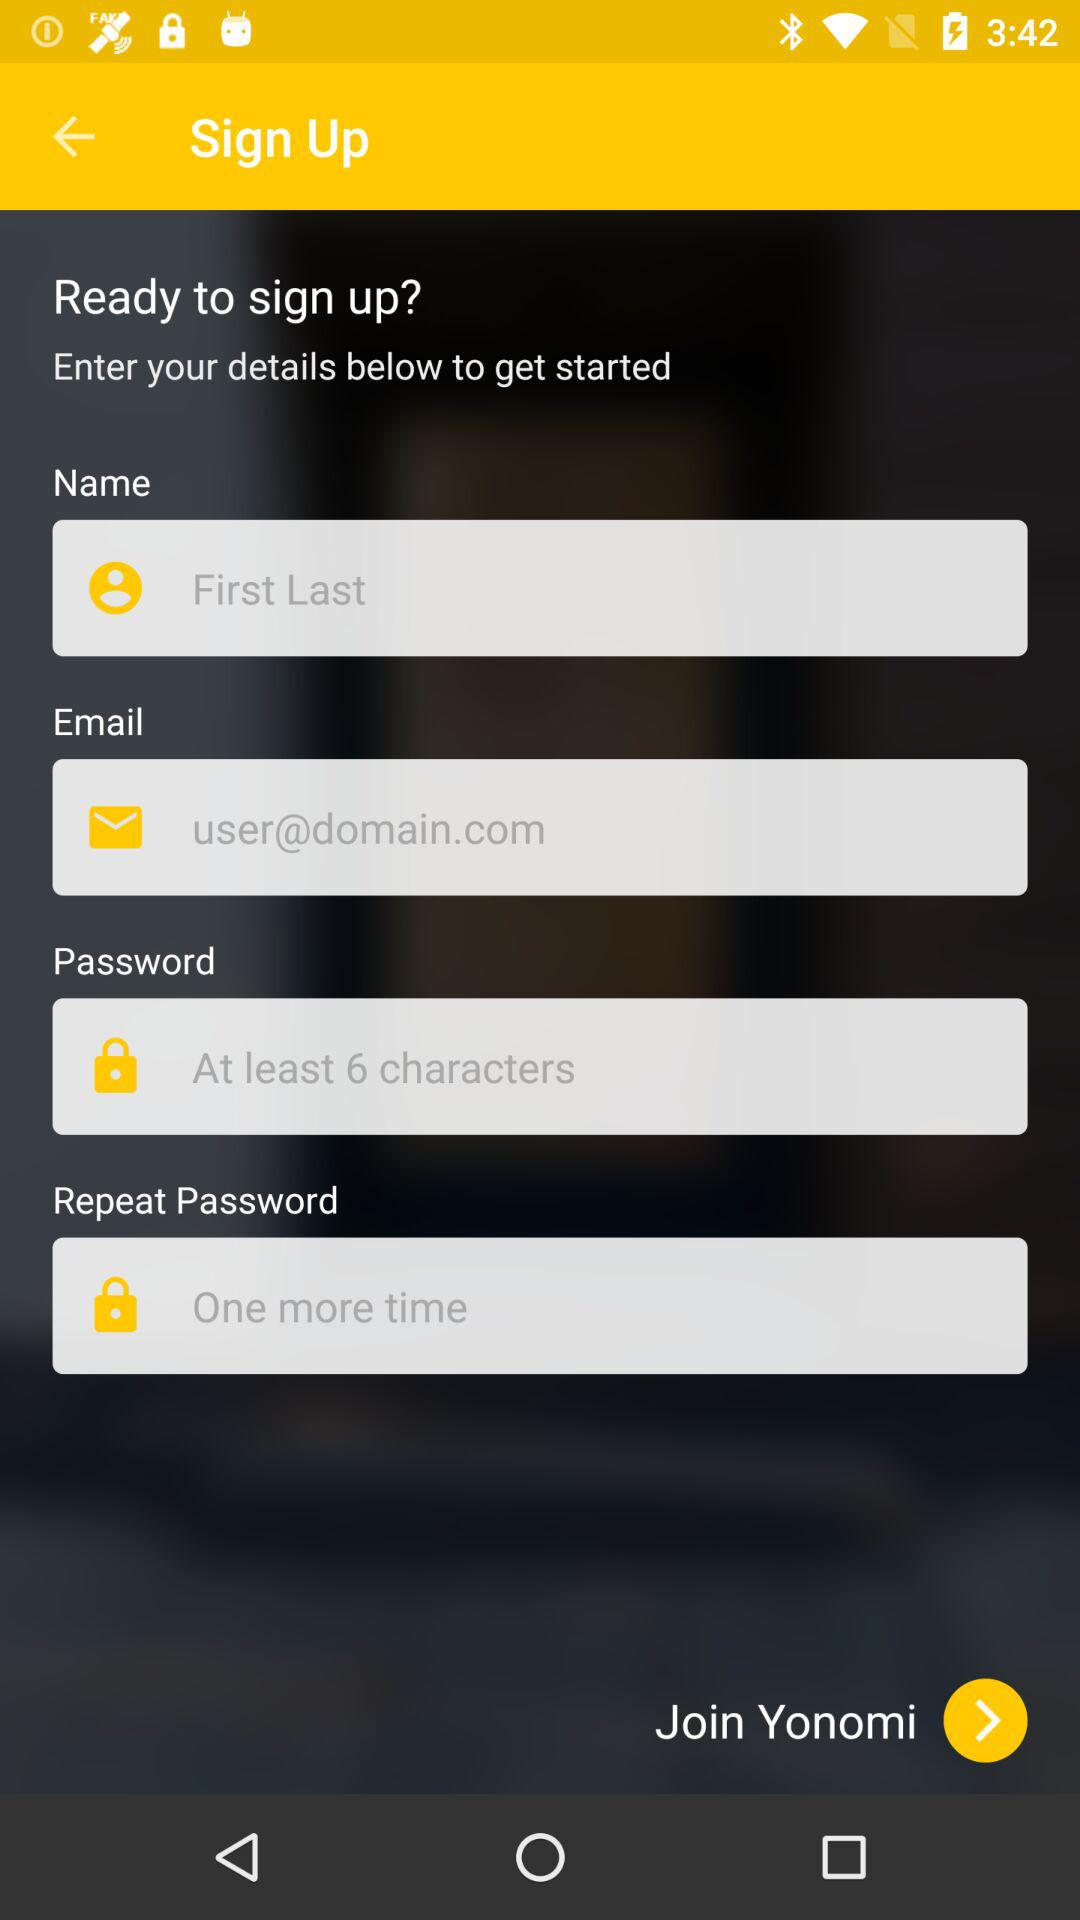How many input fields are there for the sign up form?
Answer the question using a single word or phrase. 4 